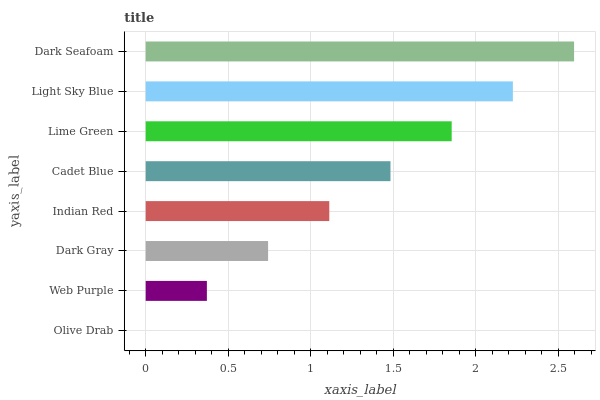Is Olive Drab the minimum?
Answer yes or no. Yes. Is Dark Seafoam the maximum?
Answer yes or no. Yes. Is Web Purple the minimum?
Answer yes or no. No. Is Web Purple the maximum?
Answer yes or no. No. Is Web Purple greater than Olive Drab?
Answer yes or no. Yes. Is Olive Drab less than Web Purple?
Answer yes or no. Yes. Is Olive Drab greater than Web Purple?
Answer yes or no. No. Is Web Purple less than Olive Drab?
Answer yes or no. No. Is Cadet Blue the high median?
Answer yes or no. Yes. Is Indian Red the low median?
Answer yes or no. Yes. Is Dark Gray the high median?
Answer yes or no. No. Is Olive Drab the low median?
Answer yes or no. No. 